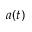Convert formula to latex. <formula><loc_0><loc_0><loc_500><loc_500>a ( t )</formula> 